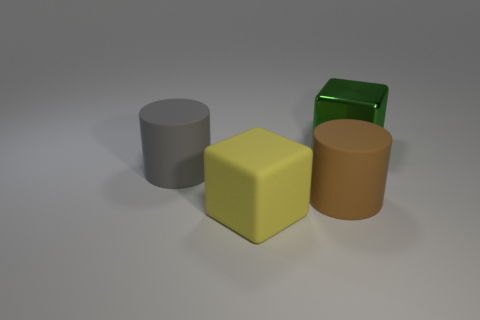There is a gray cylinder that is made of the same material as the yellow object; what is its size?
Give a very brief answer. Large. What is the shape of the big rubber object that is to the right of the gray cylinder and on the left side of the big brown object?
Provide a short and direct response. Cube. Are there an equal number of objects behind the large gray cylinder and big brown matte things?
Make the answer very short. Yes. How many things are either big matte objects or matte cylinders that are in front of the gray cylinder?
Your answer should be compact. 3. Is there another object of the same shape as the large yellow rubber thing?
Your answer should be very brief. Yes. Is the number of large yellow cubes on the left side of the yellow object the same as the number of big shiny blocks that are right of the large brown matte cylinder?
Offer a very short reply. No. What number of yellow objects are big metal objects or big things?
Your answer should be very brief. 1. How many green shiny cubes are the same size as the metallic object?
Your answer should be very brief. 0. What color is the big rubber object that is both behind the yellow object and in front of the gray matte object?
Provide a short and direct response. Brown. Is the number of big brown matte things left of the green metallic block greater than the number of small cyan shiny balls?
Give a very brief answer. Yes. 